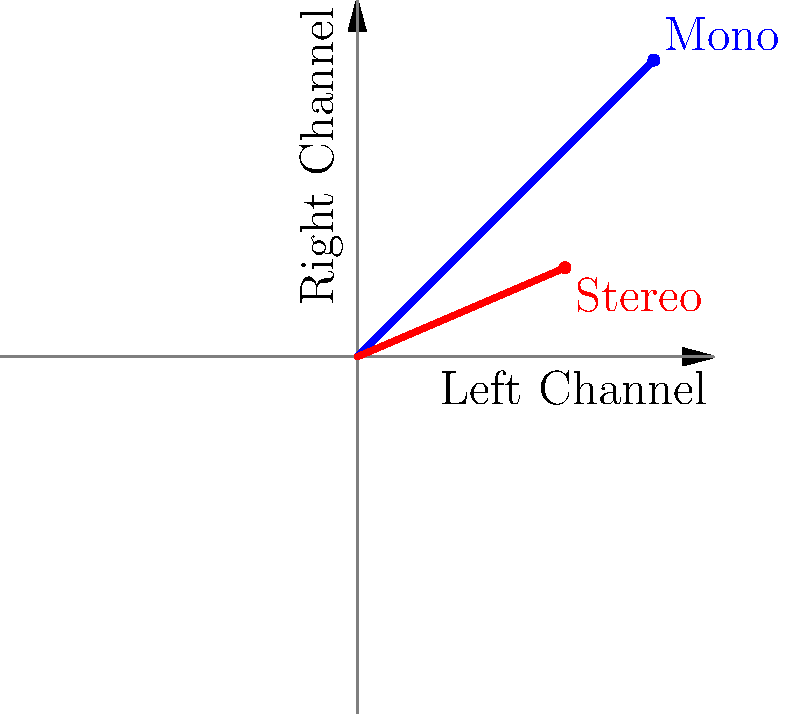In the phase diagram above, which line represents a funk recording with greater stereo separation, and why is this significant for the listening experience? To answer this question, let's analyze the phase diagram step-by-step:

1. The x-axis represents the left channel, and the y-axis represents the right channel of a stereo recording.

2. The blue line extending from (0,0) to (1,1) represents a mono recording where both channels are identical.

3. The red line extending from (0,0) to (0.7,0.3) represents a stereo recording with some degree of separation between channels.

4. Stereo separation is indicated by the deviation from the mono line (y=x).

5. The red line (stereo) shows a greater deviation from the mono line compared to the blue line.

6. This greater deviation indicates that the left and right channels contain different audio information, creating a wider soundstage.

7. In funk recordings, greater stereo separation can enhance the listening experience by:
   a) Creating a sense of space and depth in the mix
   b) Allowing individual instruments to be placed distinctly in the stereo field
   c) Enhancing the groove and rhythmic elements by separating various percussion instruments

8. The red line (stereo) represents the recording with greater stereo separation, which is significant for funk enthusiasts as it can reveal subtle nuances in the mix and provide a more immersive listening experience.
Answer: The red line; it enhances spatial perception and instrument separation in funk recordings. 